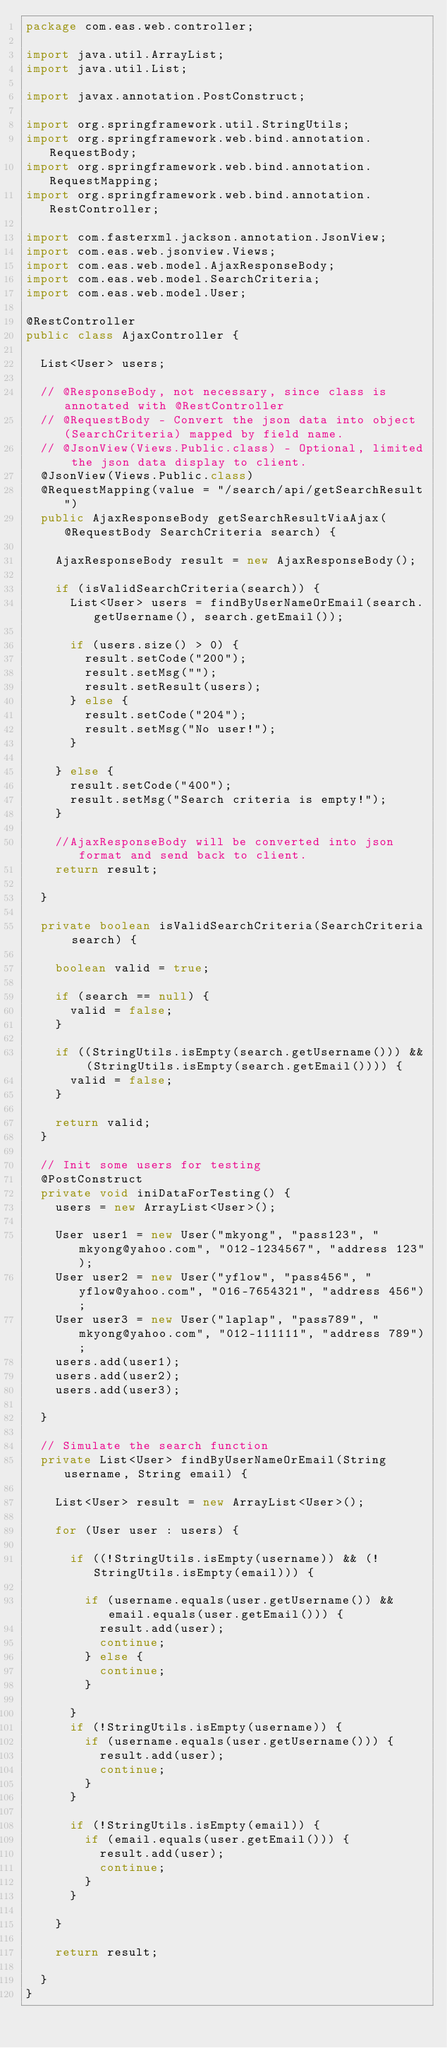Convert code to text. <code><loc_0><loc_0><loc_500><loc_500><_Java_>package com.eas.web.controller;

import java.util.ArrayList;
import java.util.List;

import javax.annotation.PostConstruct;

import org.springframework.util.StringUtils;
import org.springframework.web.bind.annotation.RequestBody;
import org.springframework.web.bind.annotation.RequestMapping;
import org.springframework.web.bind.annotation.RestController;

import com.fasterxml.jackson.annotation.JsonView;
import com.eas.web.jsonview.Views;
import com.eas.web.model.AjaxResponseBody;
import com.eas.web.model.SearchCriteria;
import com.eas.web.model.User;

@RestController
public class AjaxController {

	List<User> users;

	// @ResponseBody, not necessary, since class is annotated with @RestController
	// @RequestBody - Convert the json data into object (SearchCriteria) mapped by field name.
	// @JsonView(Views.Public.class) - Optional, limited the json data display to client.
	@JsonView(Views.Public.class)
	@RequestMapping(value = "/search/api/getSearchResult")
	public AjaxResponseBody getSearchResultViaAjax(@RequestBody SearchCriteria search) {

		AjaxResponseBody result = new AjaxResponseBody();

		if (isValidSearchCriteria(search)) {
			List<User> users = findByUserNameOrEmail(search.getUsername(), search.getEmail());

			if (users.size() > 0) {
				result.setCode("200");
				result.setMsg("");
				result.setResult(users);
			} else {
				result.setCode("204");
				result.setMsg("No user!");
			}

		} else {
			result.setCode("400");
			result.setMsg("Search criteria is empty!");
		}

		//AjaxResponseBody will be converted into json format and send back to client.
		return result;

	}

	private boolean isValidSearchCriteria(SearchCriteria search) {

		boolean valid = true;

		if (search == null) {
			valid = false;
		}

		if ((StringUtils.isEmpty(search.getUsername())) && (StringUtils.isEmpty(search.getEmail()))) {
			valid = false;
		}

		return valid;
	}

	// Init some users for testing
	@PostConstruct
	private void iniDataForTesting() {
		users = new ArrayList<User>();

		User user1 = new User("mkyong", "pass123", "mkyong@yahoo.com", "012-1234567", "address 123");
		User user2 = new User("yflow", "pass456", "yflow@yahoo.com", "016-7654321", "address 456");
		User user3 = new User("laplap", "pass789", "mkyong@yahoo.com", "012-111111", "address 789");
		users.add(user1);
		users.add(user2);
		users.add(user3);

	}

	// Simulate the search function
	private List<User> findByUserNameOrEmail(String username, String email) {

		List<User> result = new ArrayList<User>();

		for (User user : users) {

			if ((!StringUtils.isEmpty(username)) && (!StringUtils.isEmpty(email))) {

				if (username.equals(user.getUsername()) && email.equals(user.getEmail())) {
					result.add(user);
					continue;
				} else {
					continue;
				}

			}
			if (!StringUtils.isEmpty(username)) {
				if (username.equals(user.getUsername())) {
					result.add(user);
					continue;
				}
			}

			if (!StringUtils.isEmpty(email)) {
				if (email.equals(user.getEmail())) {
					result.add(user);
					continue;
				}
			}

		}

		return result;

	}
}
</code> 